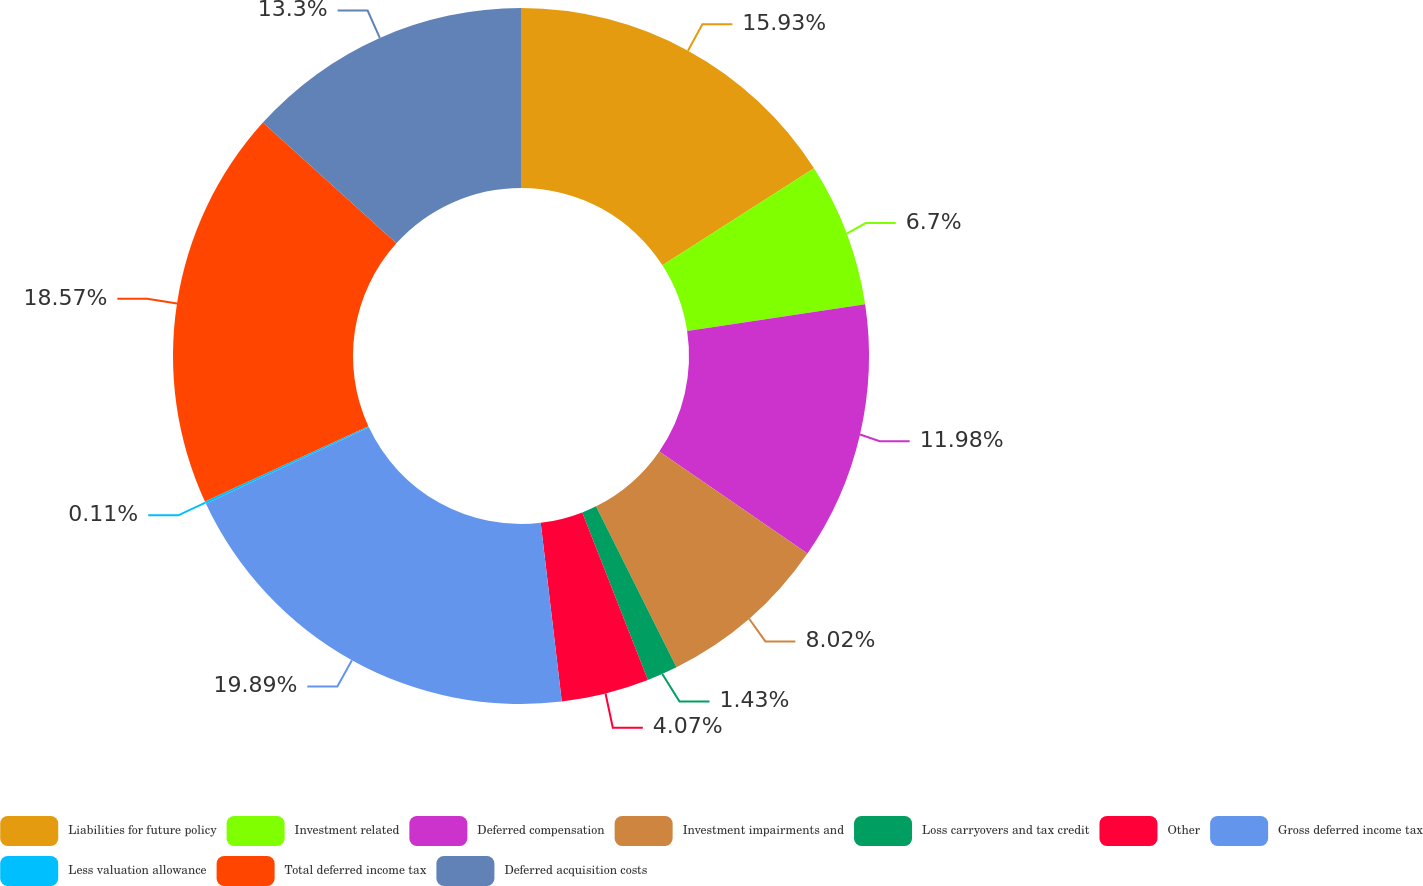<chart> <loc_0><loc_0><loc_500><loc_500><pie_chart><fcel>Liabilities for future policy<fcel>Investment related<fcel>Deferred compensation<fcel>Investment impairments and<fcel>Loss carryovers and tax credit<fcel>Other<fcel>Gross deferred income tax<fcel>Less valuation allowance<fcel>Total deferred income tax<fcel>Deferred acquisition costs<nl><fcel>15.93%<fcel>6.7%<fcel>11.98%<fcel>8.02%<fcel>1.43%<fcel>4.07%<fcel>19.89%<fcel>0.11%<fcel>18.57%<fcel>13.3%<nl></chart> 